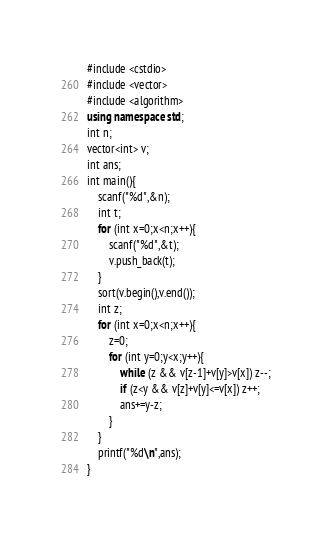Convert code to text. <code><loc_0><loc_0><loc_500><loc_500><_C++_>#include <cstdio>
#include <vector>
#include <algorithm>
using namespace std;
int n;
vector<int> v;
int ans;
int main(){
    scanf("%d",&n);
    int t;
    for (int x=0;x<n;x++){
        scanf("%d",&t);
        v.push_back(t);
    }
    sort(v.begin(),v.end());
    int z;
    for (int x=0;x<n;x++){
        z=0;
        for (int y=0;y<x;y++){
            while (z && v[z-1]+v[y]>v[x]) z--;
            if (z<y && v[z]+v[y]<=v[x]) z++;
            ans+=y-z;
        }
    }
    printf("%d\n",ans);
}
</code> 